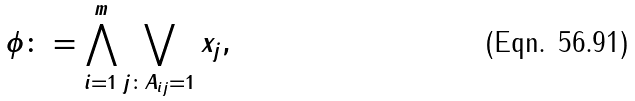Convert formula to latex. <formula><loc_0><loc_0><loc_500><loc_500>\phi \colon = \bigwedge _ { i = 1 } ^ { m } \bigvee _ { j \colon A _ { i j } = 1 } x _ { j } ,</formula> 